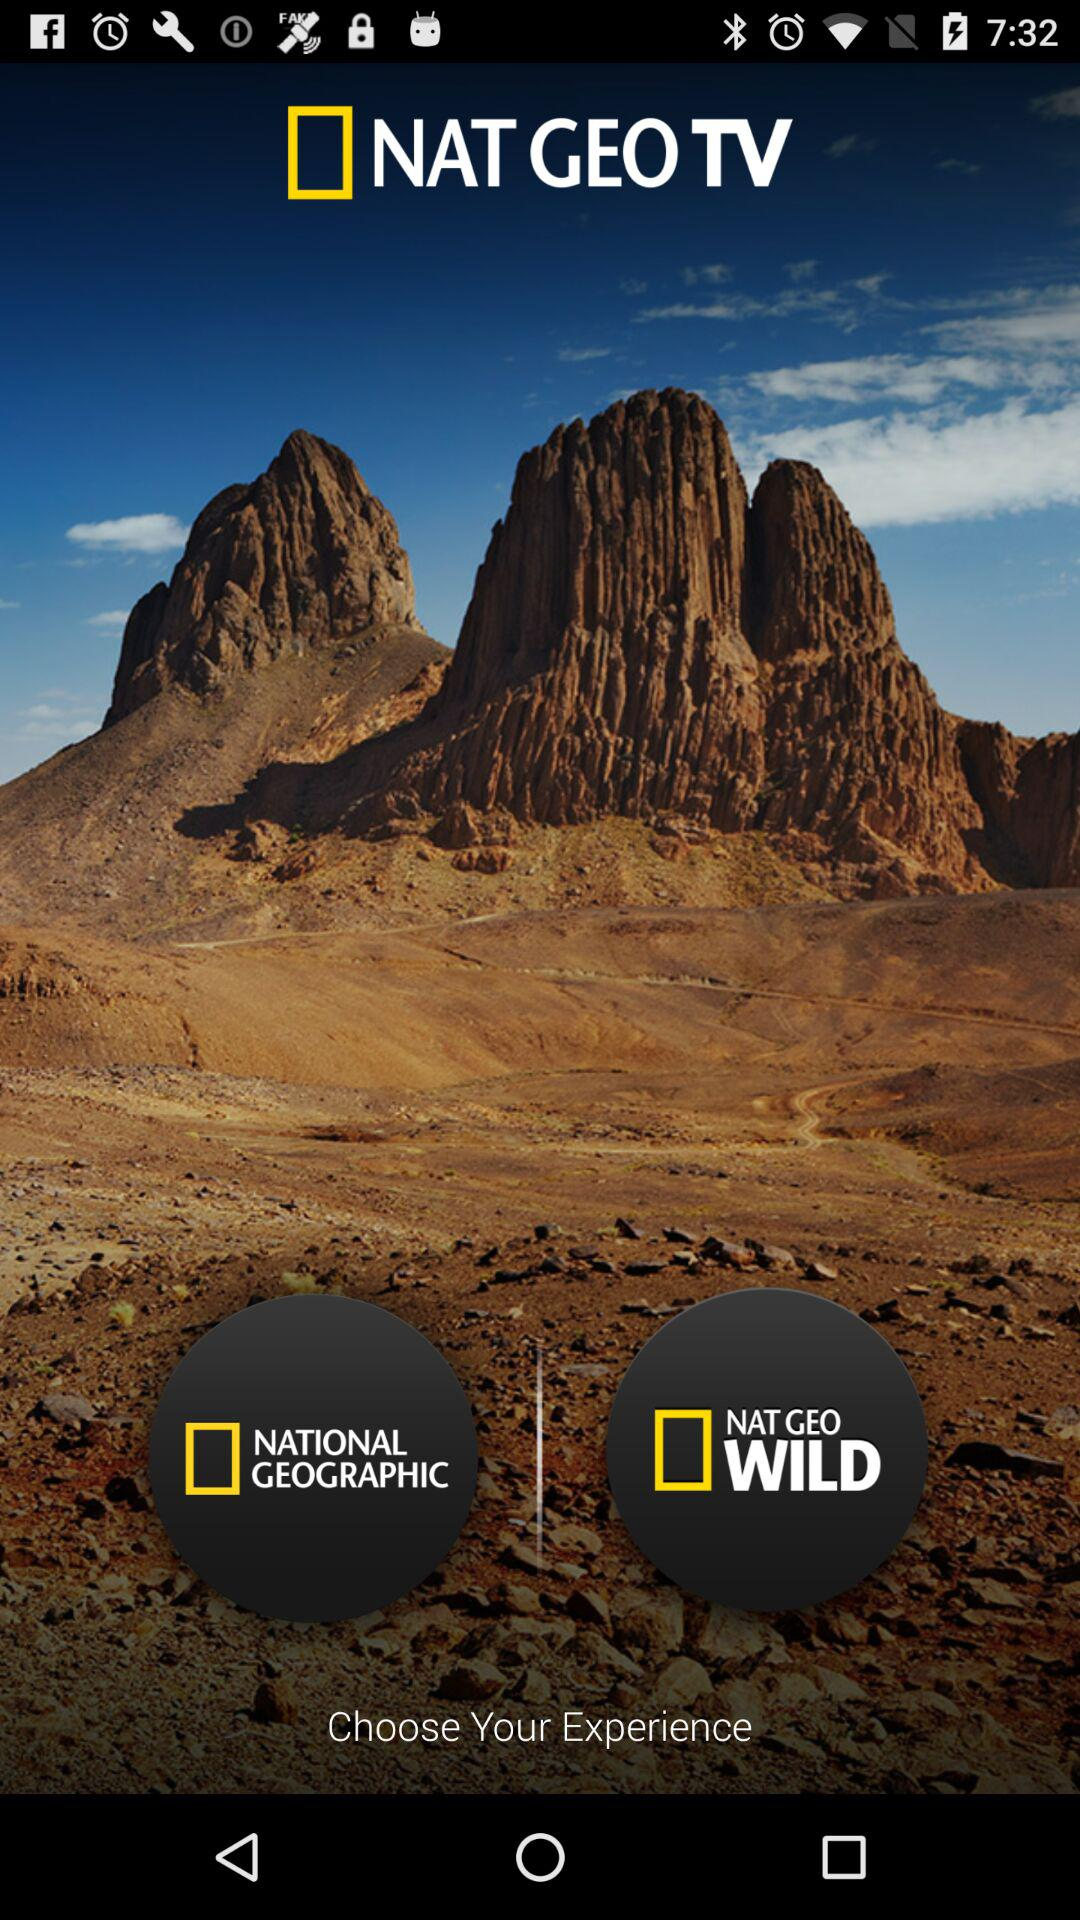What is the name of the application? The name of the application is "NAT GEO TV". 